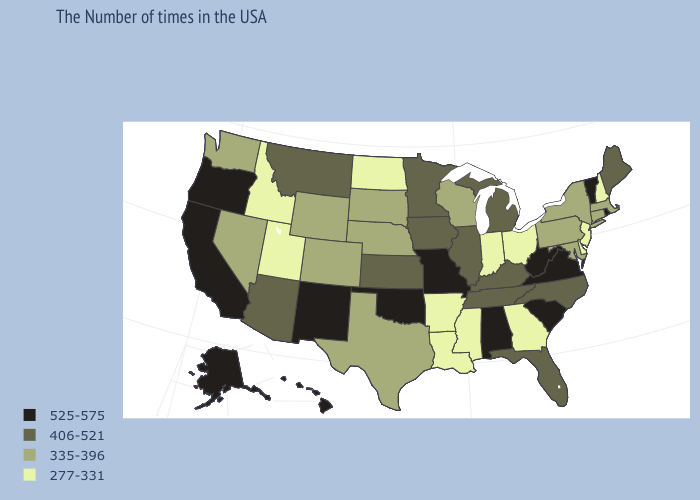Name the states that have a value in the range 335-396?
Keep it brief. Massachusetts, Connecticut, New York, Maryland, Pennsylvania, Wisconsin, Nebraska, Texas, South Dakota, Wyoming, Colorado, Nevada, Washington. Name the states that have a value in the range 335-396?
Concise answer only. Massachusetts, Connecticut, New York, Maryland, Pennsylvania, Wisconsin, Nebraska, Texas, South Dakota, Wyoming, Colorado, Nevada, Washington. Which states hav the highest value in the Northeast?
Write a very short answer. Rhode Island, Vermont. Name the states that have a value in the range 406-521?
Short answer required. Maine, North Carolina, Florida, Michigan, Kentucky, Tennessee, Illinois, Minnesota, Iowa, Kansas, Montana, Arizona. What is the value of Tennessee?
Short answer required. 406-521. Does Minnesota have the highest value in the MidWest?
Quick response, please. No. What is the value of New Hampshire?
Answer briefly. 277-331. Name the states that have a value in the range 406-521?
Give a very brief answer. Maine, North Carolina, Florida, Michigan, Kentucky, Tennessee, Illinois, Minnesota, Iowa, Kansas, Montana, Arizona. Name the states that have a value in the range 277-331?
Concise answer only. New Hampshire, New Jersey, Delaware, Ohio, Georgia, Indiana, Mississippi, Louisiana, Arkansas, North Dakota, Utah, Idaho. What is the value of Washington?
Write a very short answer. 335-396. What is the highest value in the USA?
Give a very brief answer. 525-575. What is the value of Arkansas?
Give a very brief answer. 277-331. What is the value of Maine?
Be succinct. 406-521. What is the value of Connecticut?
Be succinct. 335-396. Does Washington have the lowest value in the USA?
Keep it brief. No. 